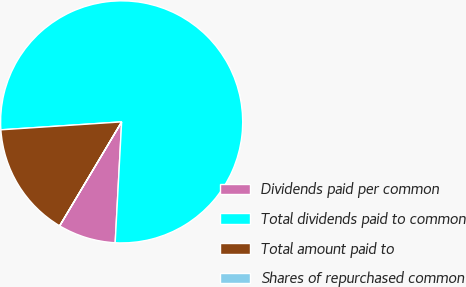Convert chart to OTSL. <chart><loc_0><loc_0><loc_500><loc_500><pie_chart><fcel>Dividends paid per common<fcel>Total dividends paid to common<fcel>Total amount paid to<fcel>Shares of repurchased common<nl><fcel>7.7%<fcel>76.89%<fcel>15.39%<fcel>0.01%<nl></chart> 